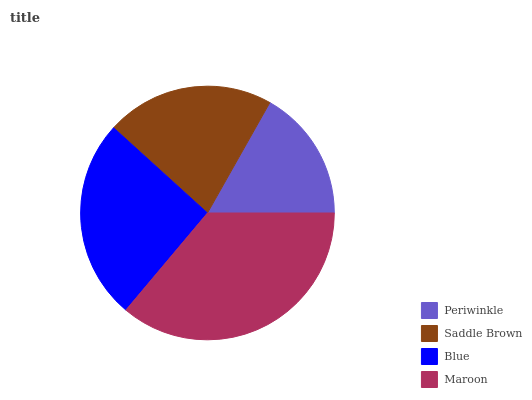Is Periwinkle the minimum?
Answer yes or no. Yes. Is Maroon the maximum?
Answer yes or no. Yes. Is Saddle Brown the minimum?
Answer yes or no. No. Is Saddle Brown the maximum?
Answer yes or no. No. Is Saddle Brown greater than Periwinkle?
Answer yes or no. Yes. Is Periwinkle less than Saddle Brown?
Answer yes or no. Yes. Is Periwinkle greater than Saddle Brown?
Answer yes or no. No. Is Saddle Brown less than Periwinkle?
Answer yes or no. No. Is Blue the high median?
Answer yes or no. Yes. Is Saddle Brown the low median?
Answer yes or no. Yes. Is Periwinkle the high median?
Answer yes or no. No. Is Periwinkle the low median?
Answer yes or no. No. 